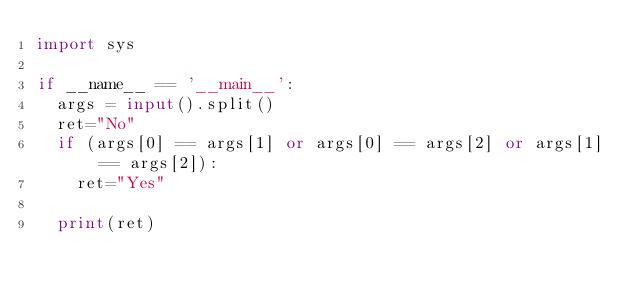Convert code to text. <code><loc_0><loc_0><loc_500><loc_500><_Python_>import sys
 
if __name__ == '__main__':
  args = input().split()
  ret="No"
  if (args[0] == args[1] or args[0] == args[2] or args[1] == args[2]):
    ret="Yes"
    
  print(ret)
</code> 